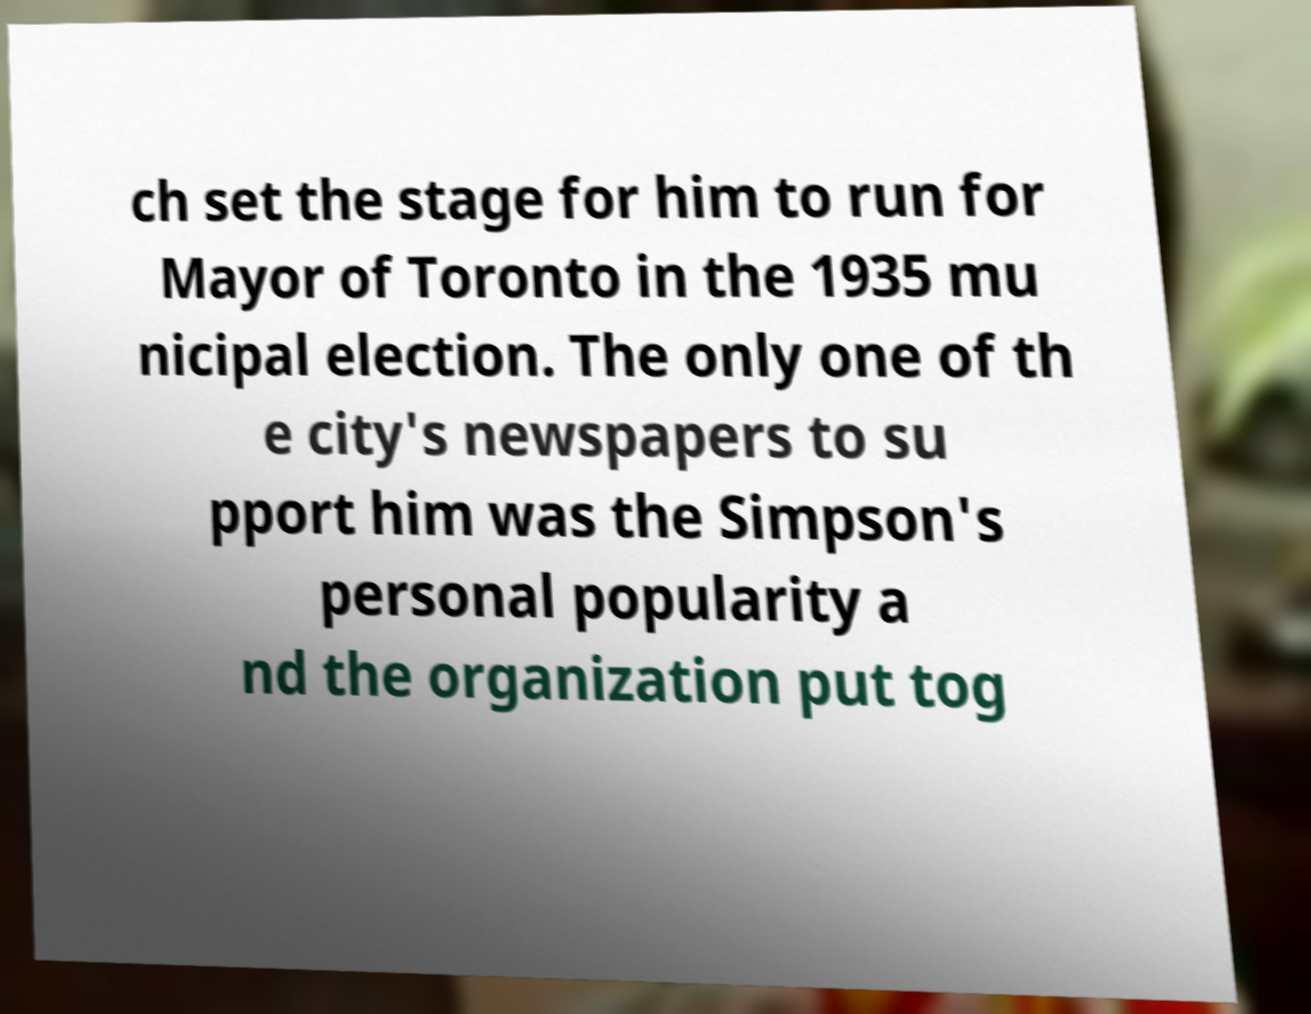Can you accurately transcribe the text from the provided image for me? ch set the stage for him to run for Mayor of Toronto in the 1935 mu nicipal election. The only one of th e city's newspapers to su pport him was the Simpson's personal popularity a nd the organization put tog 